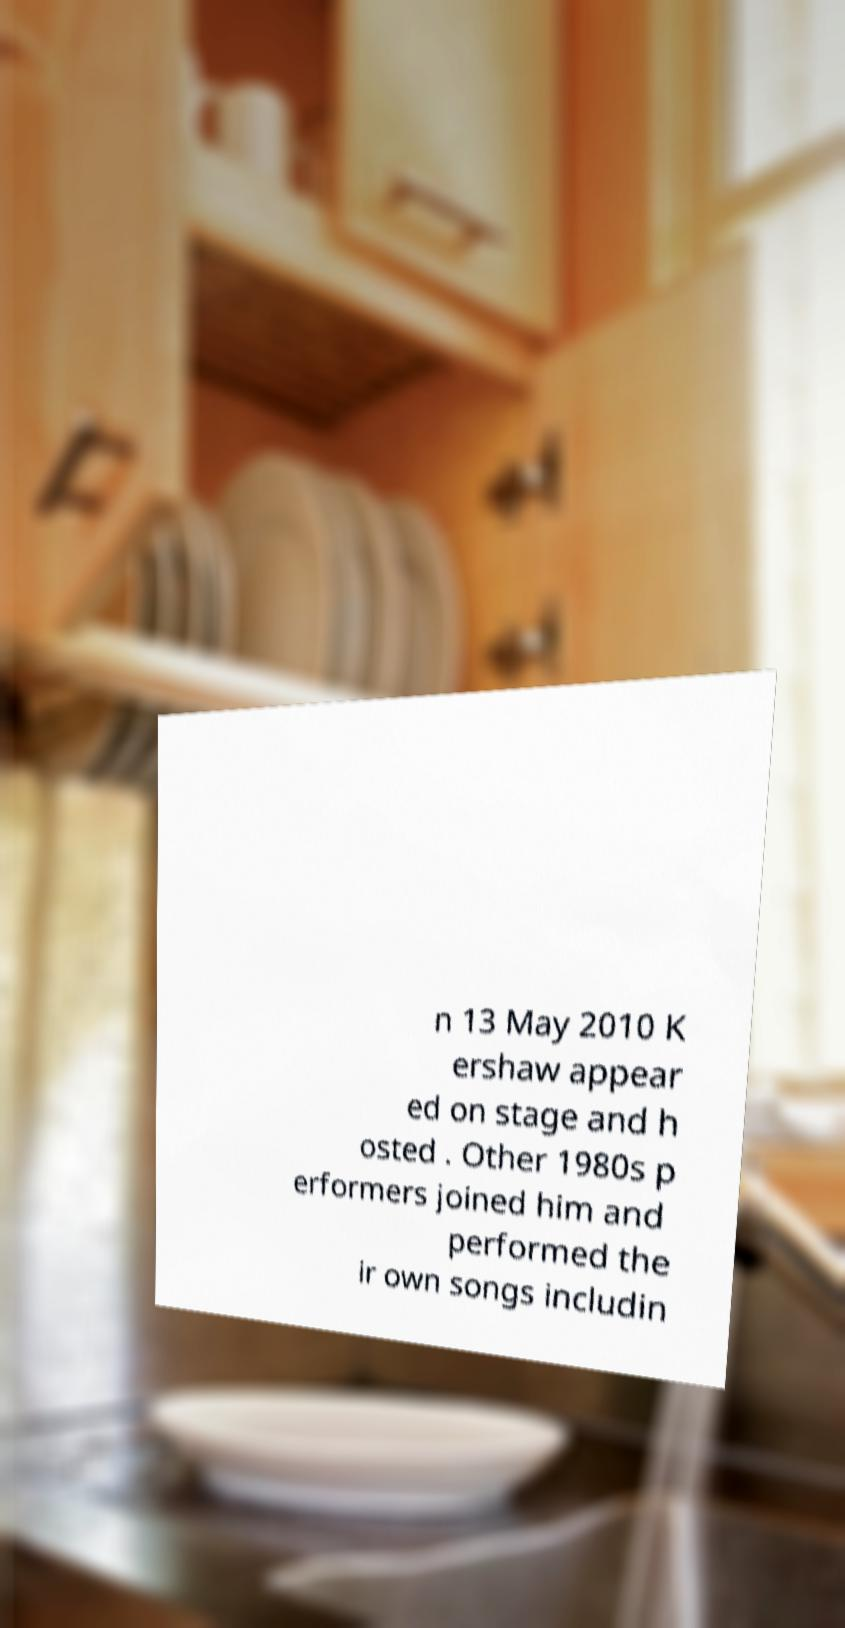Can you read and provide the text displayed in the image?This photo seems to have some interesting text. Can you extract and type it out for me? n 13 May 2010 K ershaw appear ed on stage and h osted . Other 1980s p erformers joined him and performed the ir own songs includin 